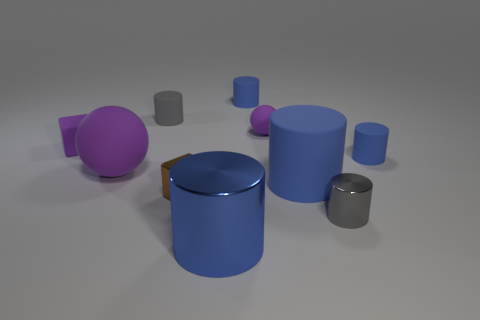Do the large rubber cylinder and the large metal cylinder have the same color?
Your answer should be compact. Yes. What size is the cube that is the same color as the small rubber sphere?
Your answer should be compact. Small. Do the metal cylinder behind the blue shiny thing and the brown metallic thing that is on the left side of the large shiny object have the same size?
Make the answer very short. Yes. How many small spheres have the same color as the small matte block?
Keep it short and to the point. 1. There is a large ball that is the same color as the tiny rubber block; what material is it?
Ensure brevity in your answer.  Rubber. Is the number of small rubber cylinders that are in front of the small matte sphere greater than the number of green shiny cylinders?
Offer a very short reply. Yes. Is the shape of the large shiny thing the same as the small gray metal thing?
Provide a short and direct response. Yes. How many other cubes are the same material as the small brown block?
Provide a short and direct response. 0. There is another rubber object that is the same shape as the large purple object; what is its size?
Offer a terse response. Small. Is the size of the purple matte cube the same as the brown cube?
Offer a very short reply. Yes. 